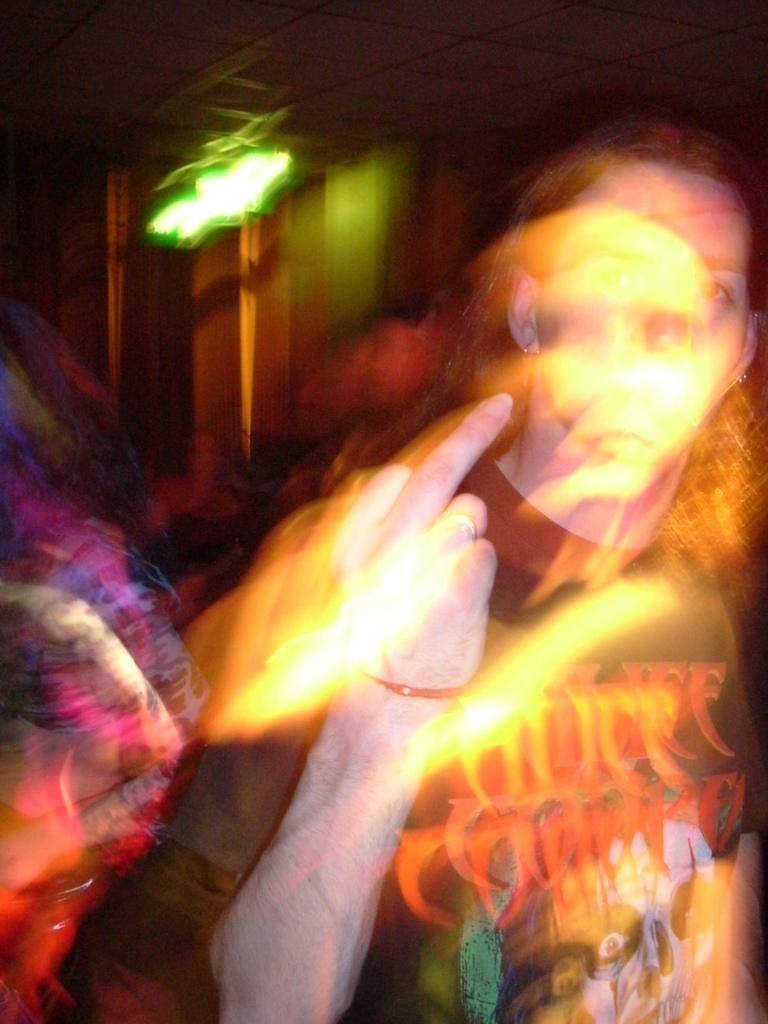Who or what is present in the image? There is a person in the image. What is the person wearing? The person is wearing a black shirt. What can be seen in addition to the person? There are lights visible in the image. Can you describe the background of the image? The background of the image is blurred. How does the hen contribute to the pollution in the image? There is no hen present in the image, so it cannot contribute to any pollution. 